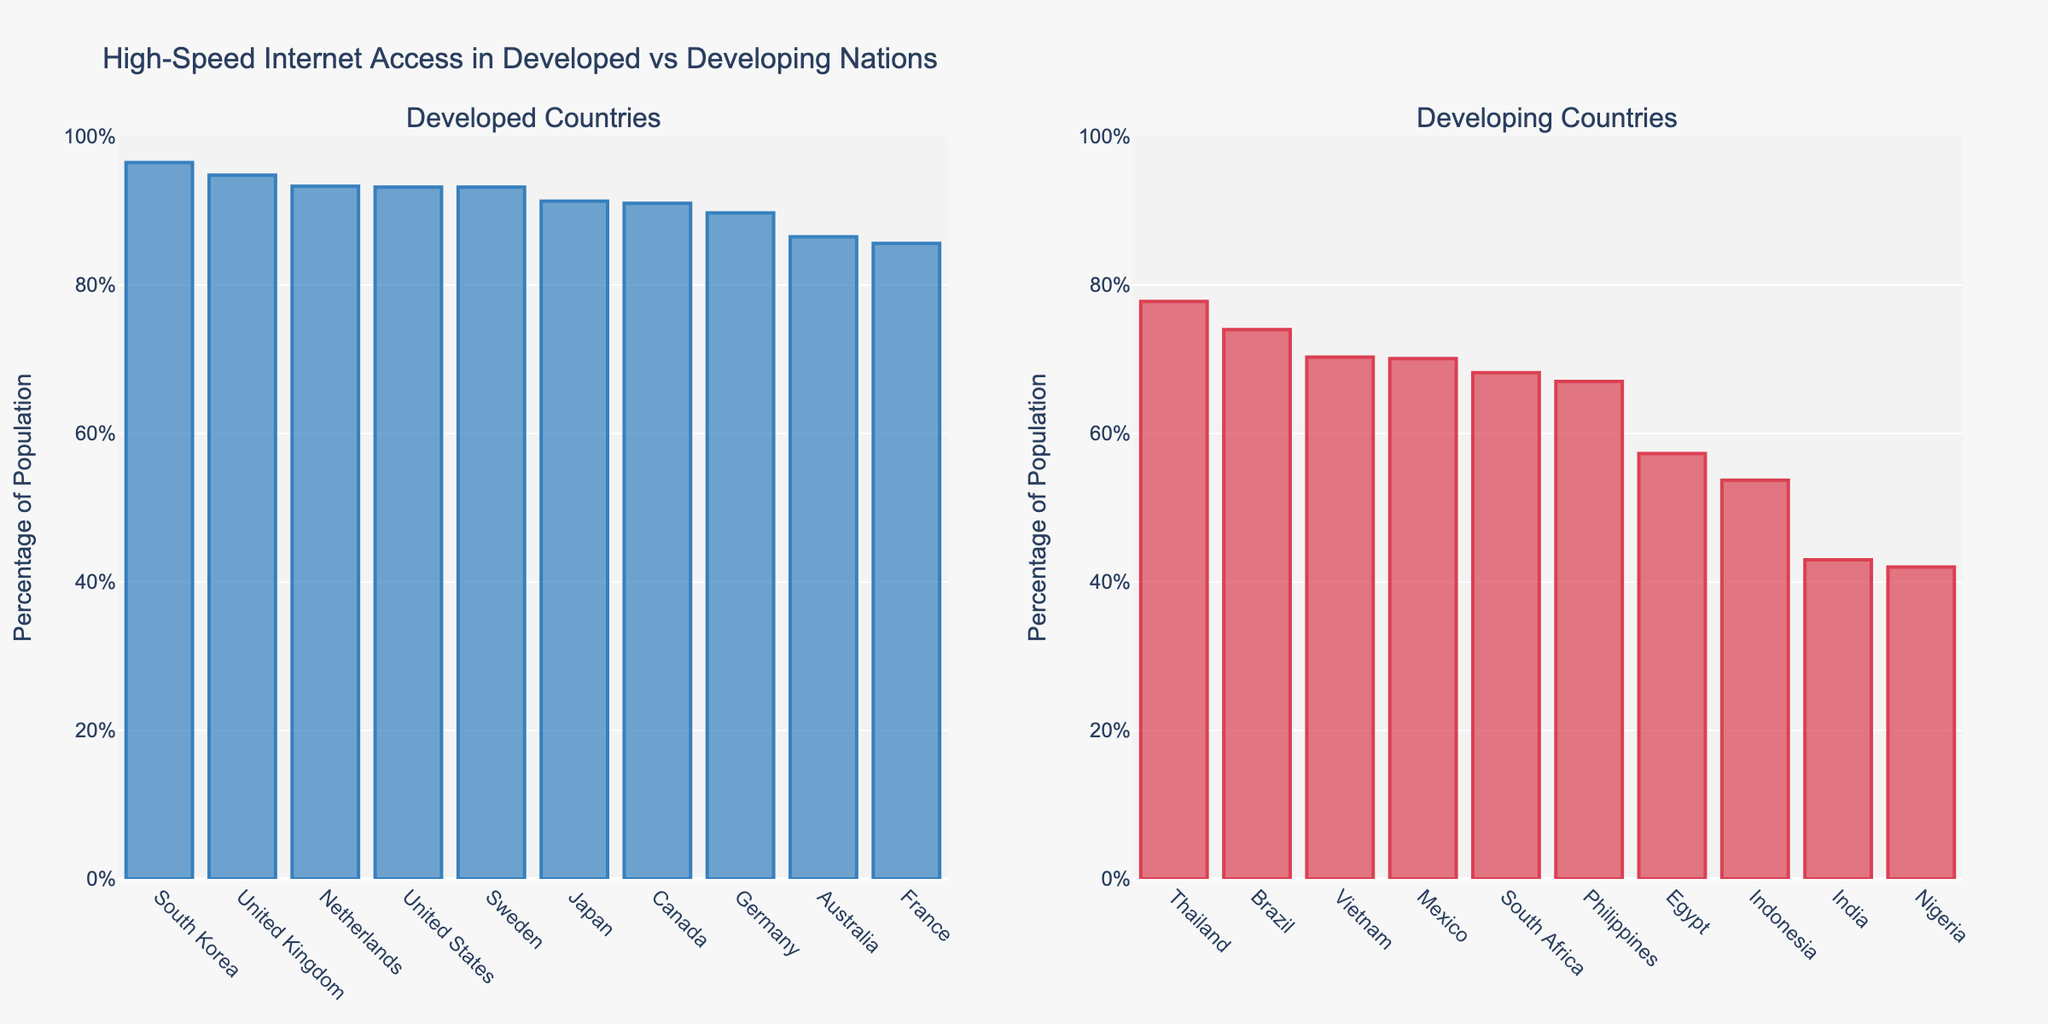What is the country with the highest percentage of population with access to high-speed internet among developing nations? To answer this question, look at the bars in the chart for developing countries and identify the one that reaches the highest percentage. Thailand has the tallest bar among developing nations.
Answer: Thailand Which developed country has the lowest percentage of population with access to high-speed internet? To find this, look at the bars in the chart for developed countries and find the shortest bar. France has the shortest bar among developed nations.
Answer: France What is the average percentage of population with access to high-speed internet among developing countries? To calculate the average, sum the percentages for all developing countries and divide by the number of these countries: (43.0 + 74.0 + 53.7 + 42.0 + 57.3 + 67.0 + 70.3 + 68.2 + 70.1 + 77.8) / 10 =  623.4 / 10 = 62.34
Answer: 62.34 Which country has a higher percentage of population with high-speed internet access, Brazil or Vietnam? Compare the heights of the bars for Brazil and Vietnam in the developing countries chart. Brazil's bar reaches 74.0%, while Vietnam's bar reaches 70.3%. Therefore, Brazil has a higher percentage.
Answer: Brazil By how much does the percentage of population with high-speed internet access in the United States exceed that in Canada? Look at the bars for the United States and Canada and subtract the latter's percentage from the former's. The U.S. has 93.2% and Canada has 91.0%. So, the difference is 93,2% - 91.0% = 2.2%.
Answer: 2.2 What's the sum of the internet access percentages of the top three countries in the developed category? Identify the top three bars in the developed countries category, which are South Korea (96.5%), United Kingdom (94.8%), and Netherlands (93.3%). Add these percentages: 96.5 + 94.8 + 93.3 = 284.6.
Answer: 284.6 How much less is the percentage of high-speed internet access in Nigeria compared to Egypt? Identify and compare the bars for Nigeria and Egypt in the developing countries. Nigeria has 42.0% and Egypt has 57.3%, so the difference is 57.3% - 42.0% = 15.3%.
Answer: 15.3 Which country stands out visually in the developing nations for having a much higher percentage than others? A country that stands out visually would have a distinctively taller bar compared to others. Thailand's bar is notably taller than most other developing countries.
Answer: Thailand Is there any developed country with an internet access percentage less than 90%? Check the bars in the developed nations chart and see if any of them fall below the 90% mark. France (85.6%) and Australia (86.5%) are below 90%.
Answer: Yes What’s the difference in internet access percentage between the country with the lowest access in the developed nations and the one with the highest access in the developing nations? Identify France (85.6%) as the lowest in the developed nations and Thailand (77.8%) as the highest in the developing nations. The difference is 85.6% - 77.8% = 7.8%.
Answer: 7.8 